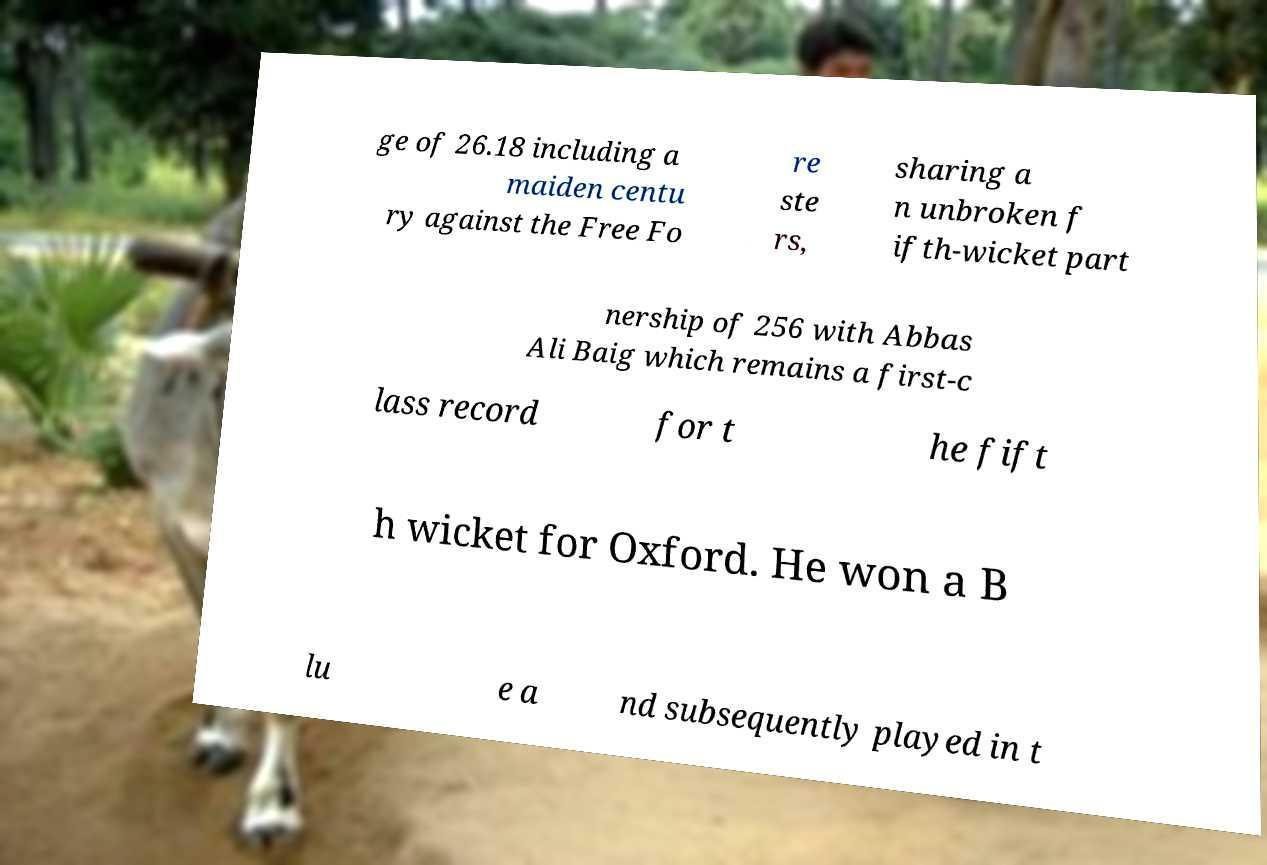For documentation purposes, I need the text within this image transcribed. Could you provide that? ge of 26.18 including a maiden centu ry against the Free Fo re ste rs, sharing a n unbroken f ifth-wicket part nership of 256 with Abbas Ali Baig which remains a first-c lass record for t he fift h wicket for Oxford. He won a B lu e a nd subsequently played in t 